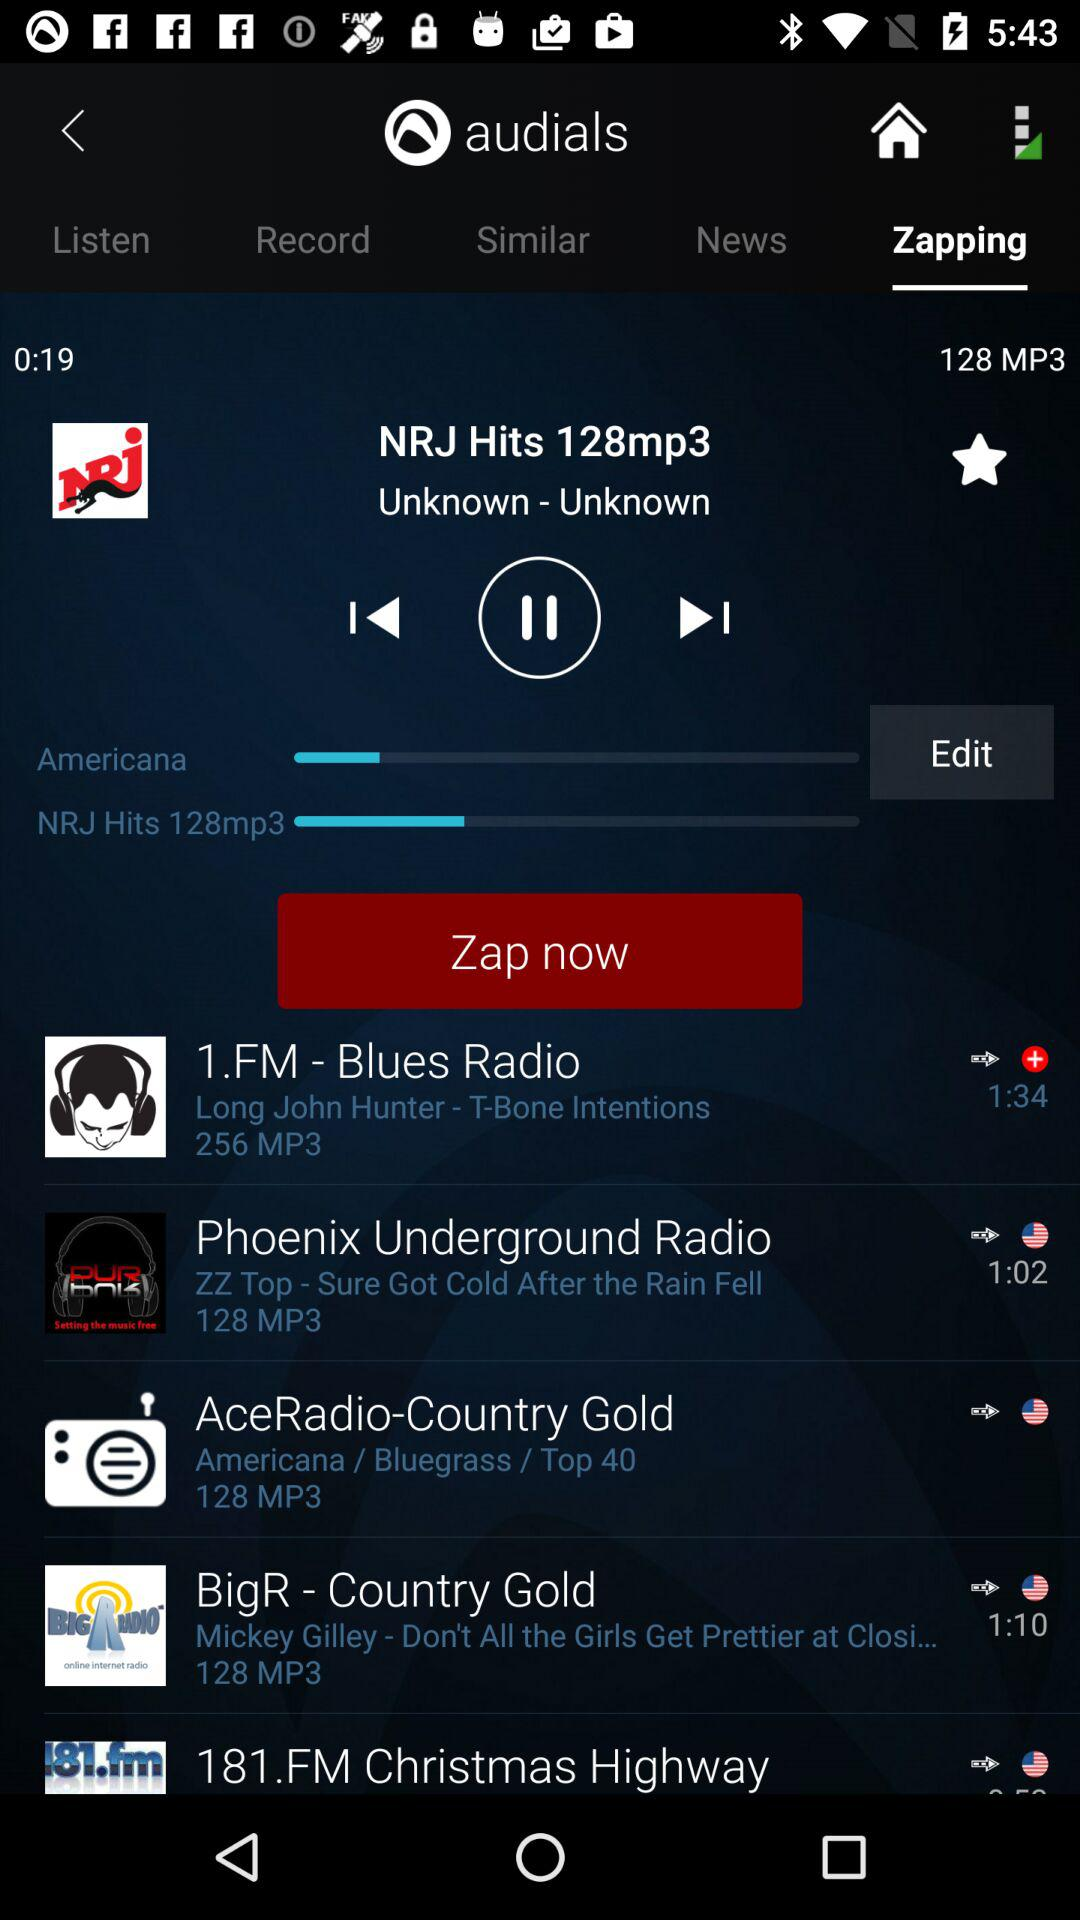Which tab is currently selected? The currently selected tab is "Zapping". 